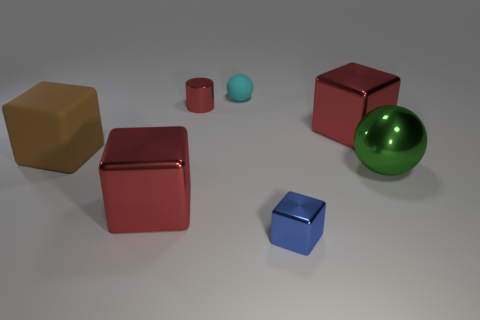Subtract all tiny blocks. How many blocks are left? 3 Subtract all brown spheres. How many red blocks are left? 2 Subtract all blue blocks. How many blocks are left? 3 Add 1 tiny cyan balls. How many objects exist? 8 Subtract all green cubes. Subtract all red spheres. How many cubes are left? 4 Subtract all small metal cubes. Subtract all shiny blocks. How many objects are left? 3 Add 1 green spheres. How many green spheres are left? 2 Add 7 large brown matte blocks. How many large brown matte blocks exist? 8 Subtract 0 yellow cylinders. How many objects are left? 7 Subtract all blocks. How many objects are left? 3 